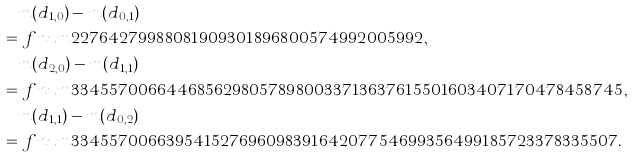<formula> <loc_0><loc_0><loc_500><loc_500>& m ( d _ { 1 , 0 } ) - m ( d _ { 0 , 1 } ) \\ = & \ f n u m { 2 2 7 6 4 2 7 9 9 8 8 0 8 1 9 0 9 3 0 1 8 9 6 8 0 0 5 7 4 9 9 2 0 0 5 9 9 2 } , \\ & m ( d _ { 2 , 0 } ) - m ( d _ { 1 , 1 } ) \\ = & \ f n u m { 3 3 4 5 5 7 0 0 6 6 4 4 6 8 5 6 2 9 8 0 5 7 8 9 8 0 0 3 3 7 1 3 6 3 7 6 1 5 5 0 1 6 0 3 4 0 7 1 7 0 4 7 8 4 5 8 7 4 5 } , \\ & m ( d _ { 1 , 1 } ) - m ( d _ { 0 , 2 } ) \\ = & \ f n u m { 3 3 4 5 5 7 0 0 6 6 3 9 5 4 1 5 2 7 6 9 6 0 9 8 3 9 1 6 4 2 0 7 7 5 4 6 9 9 3 5 6 4 9 9 1 8 5 7 2 3 3 7 8 3 3 5 5 0 7 } .</formula> 